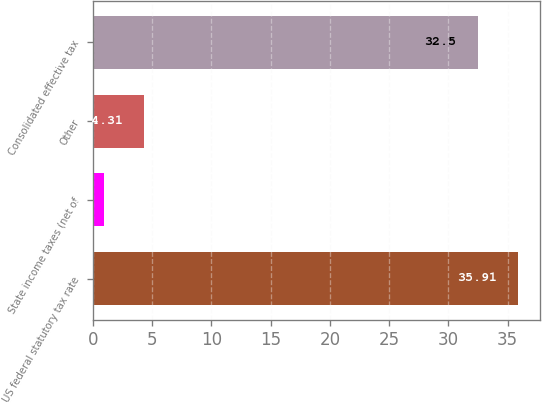<chart> <loc_0><loc_0><loc_500><loc_500><bar_chart><fcel>US federal statutory tax rate<fcel>State income taxes (net of<fcel>Other<fcel>Consolidated effective tax<nl><fcel>35.91<fcel>0.9<fcel>4.31<fcel>32.5<nl></chart> 